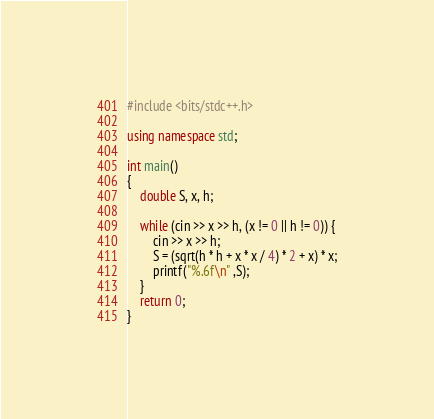<code> <loc_0><loc_0><loc_500><loc_500><_C++_>#include <bits/stdc++.h>

using namespace std;

int main()
{
    double S, x, h;
 
    while (cin >> x >> h, (x != 0 || h != 0)) {
        cin >> x >> h; 
        S = (sqrt(h * h + x * x / 4) * 2 + x) * x;
        printf("%.6f\n" ,S);
    }
    return 0;
}</code> 